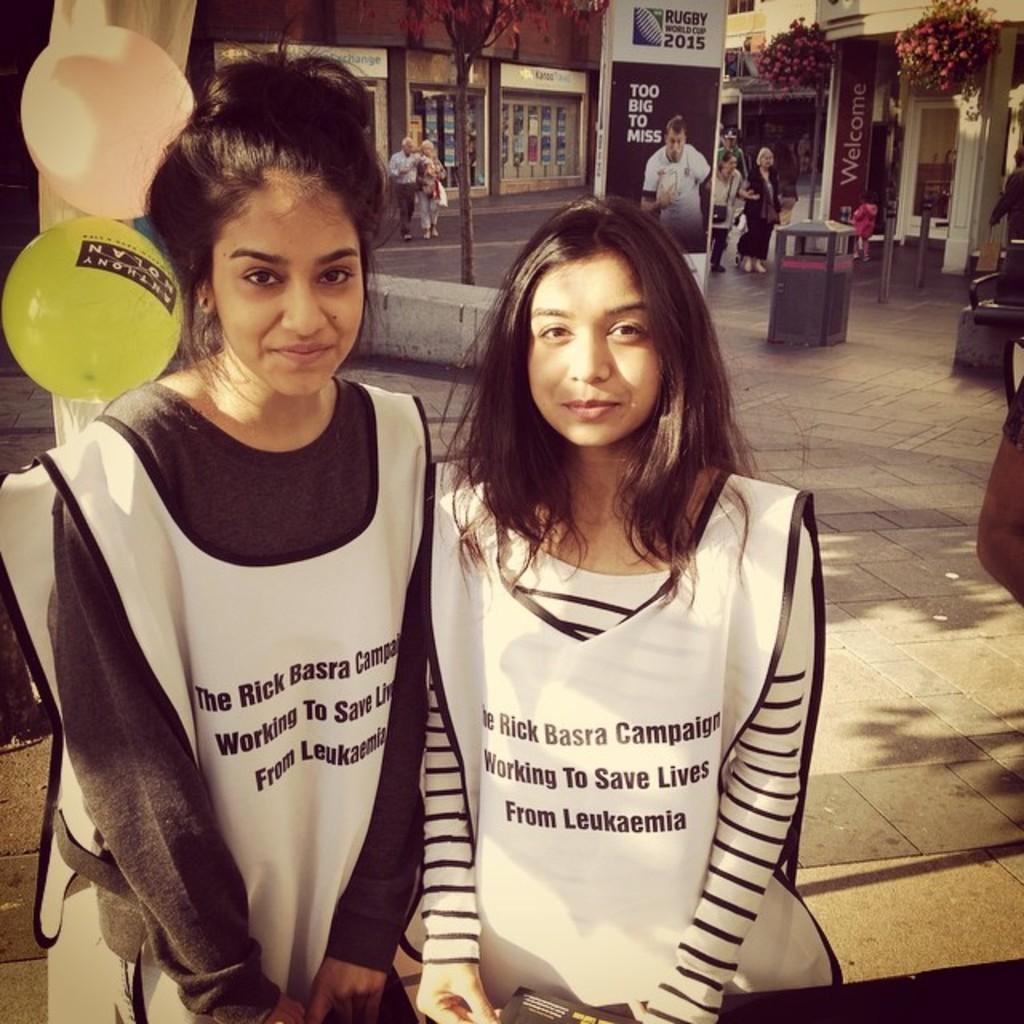Can you describe this image briefly? In this image we can see women standing on the floor. In the background there are balloons tied to a tree, creepers, advertisement boards, stores, barrier poles, bins and people on the road. 